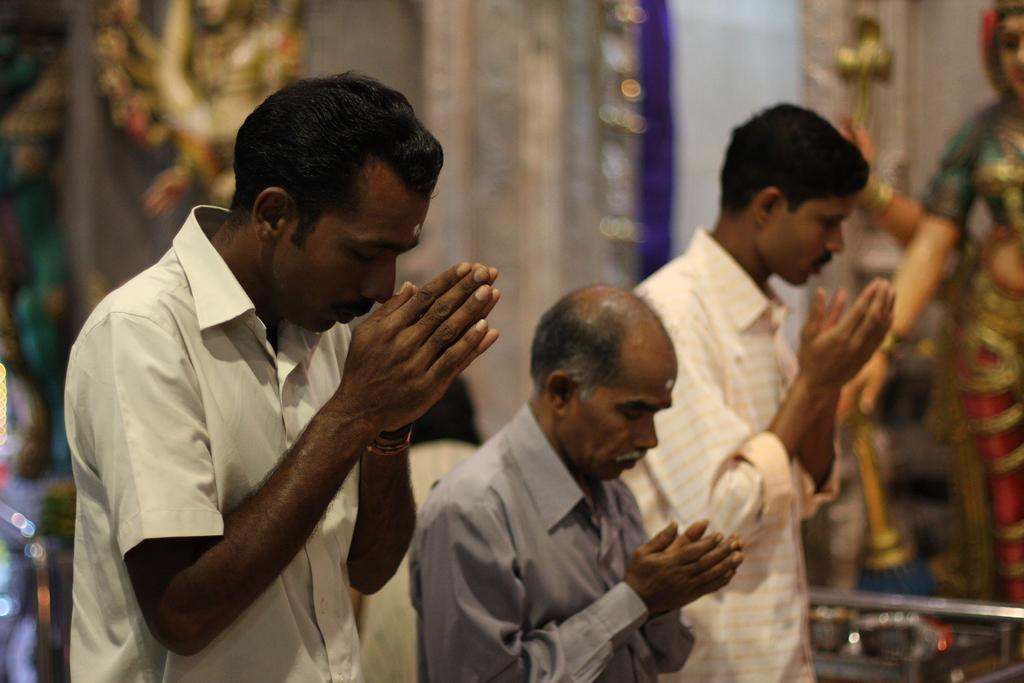How many people are in the image? There are three men in the image. What are the men doing in the image? The men are praying in the image. What can be seen behind the men? There are god idols in the image. Where are the god idols located? The god idols are in front of a wall. What type of brass instrument can be heard in the image? There is no brass instrument present in the image; it features men praying and god idols. What is the taste of the soda being consumed by the men in the image? There is no soda present in the image, as the men are praying and there are god idols. 